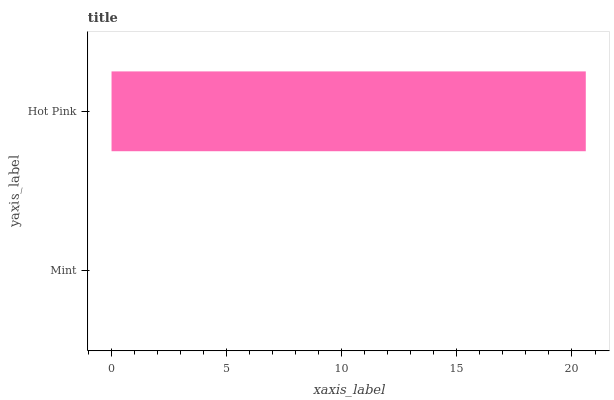Is Mint the minimum?
Answer yes or no. Yes. Is Hot Pink the maximum?
Answer yes or no. Yes. Is Hot Pink the minimum?
Answer yes or no. No. Is Hot Pink greater than Mint?
Answer yes or no. Yes. Is Mint less than Hot Pink?
Answer yes or no. Yes. Is Mint greater than Hot Pink?
Answer yes or no. No. Is Hot Pink less than Mint?
Answer yes or no. No. Is Hot Pink the high median?
Answer yes or no. Yes. Is Mint the low median?
Answer yes or no. Yes. Is Mint the high median?
Answer yes or no. No. Is Hot Pink the low median?
Answer yes or no. No. 